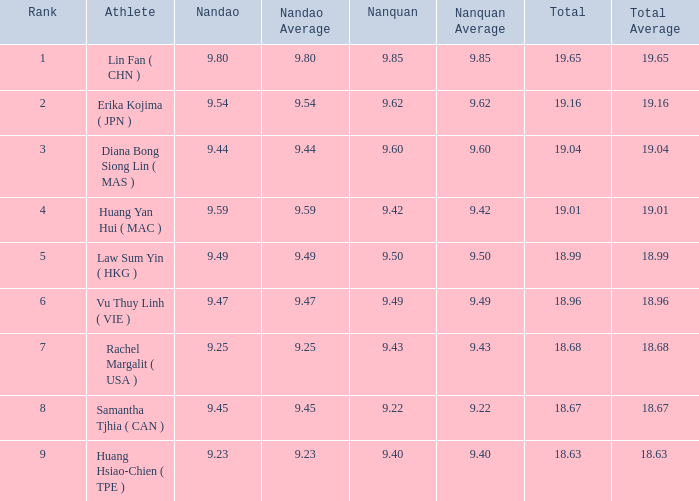Which Nanquan has a Nandao smaller than 9.44, and a Rank smaller than 9, and a Total larger than 18.68? None. 